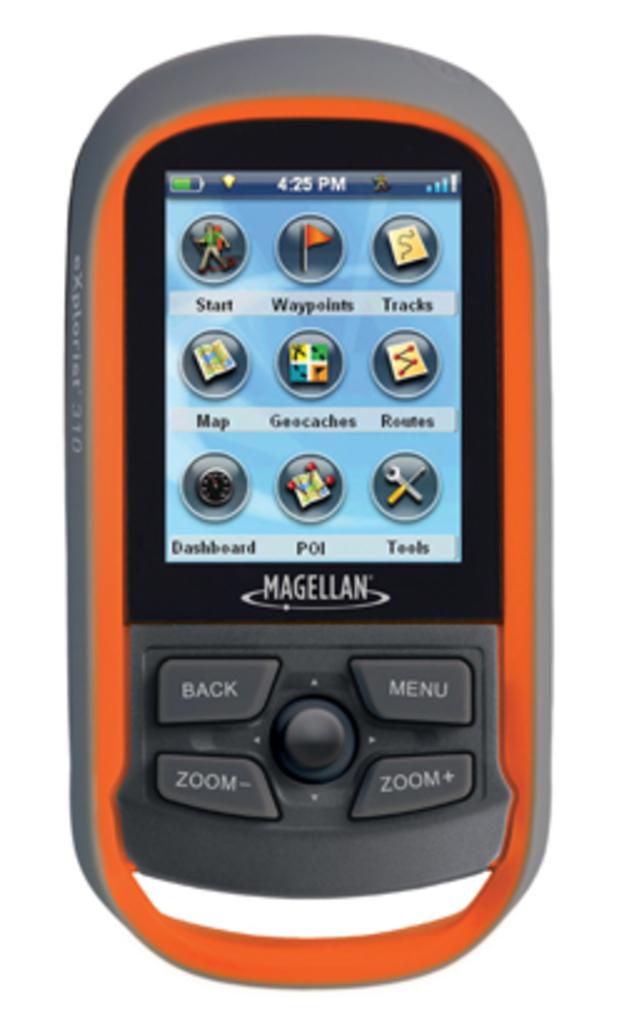<image>
Render a clear and concise summary of the photo. a magellan phone with 4:25 Pm at the top 